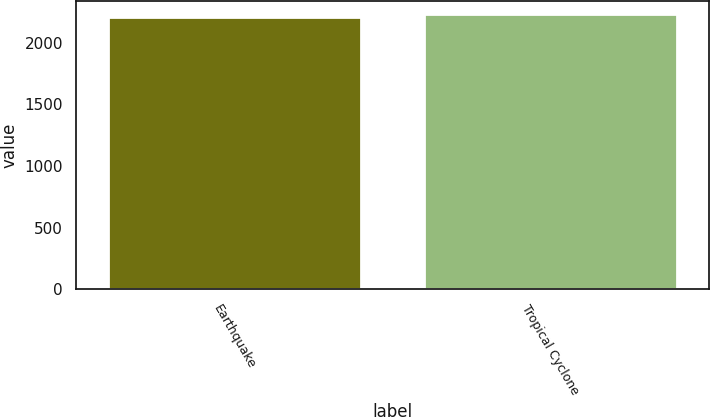Convert chart. <chart><loc_0><loc_0><loc_500><loc_500><bar_chart><fcel>Earthquake<fcel>Tropical Cyclone<nl><fcel>2208<fcel>2230<nl></chart> 